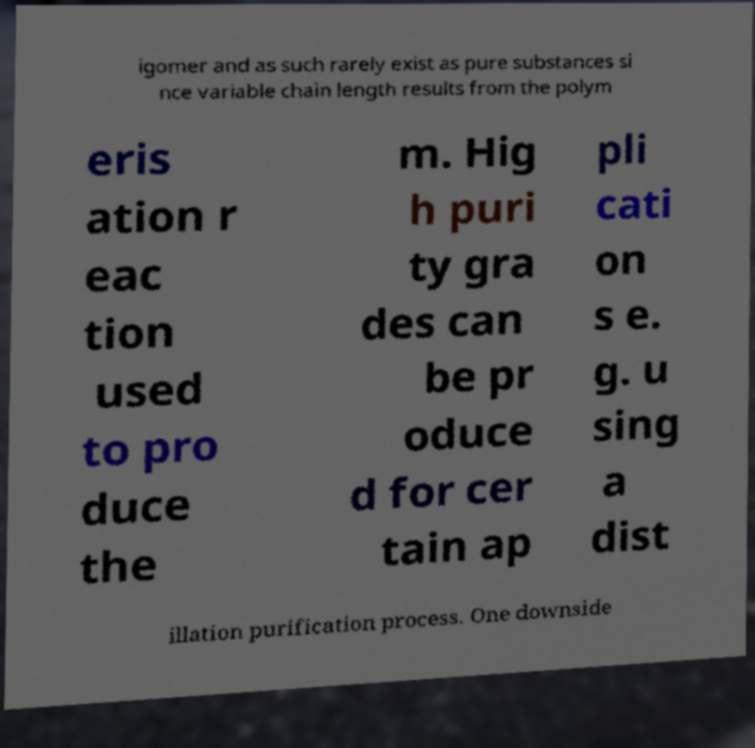I need the written content from this picture converted into text. Can you do that? igomer and as such rarely exist as pure substances si nce variable chain length results from the polym eris ation r eac tion used to pro duce the m. Hig h puri ty gra des can be pr oduce d for cer tain ap pli cati on s e. g. u sing a dist illation purification process. One downside 